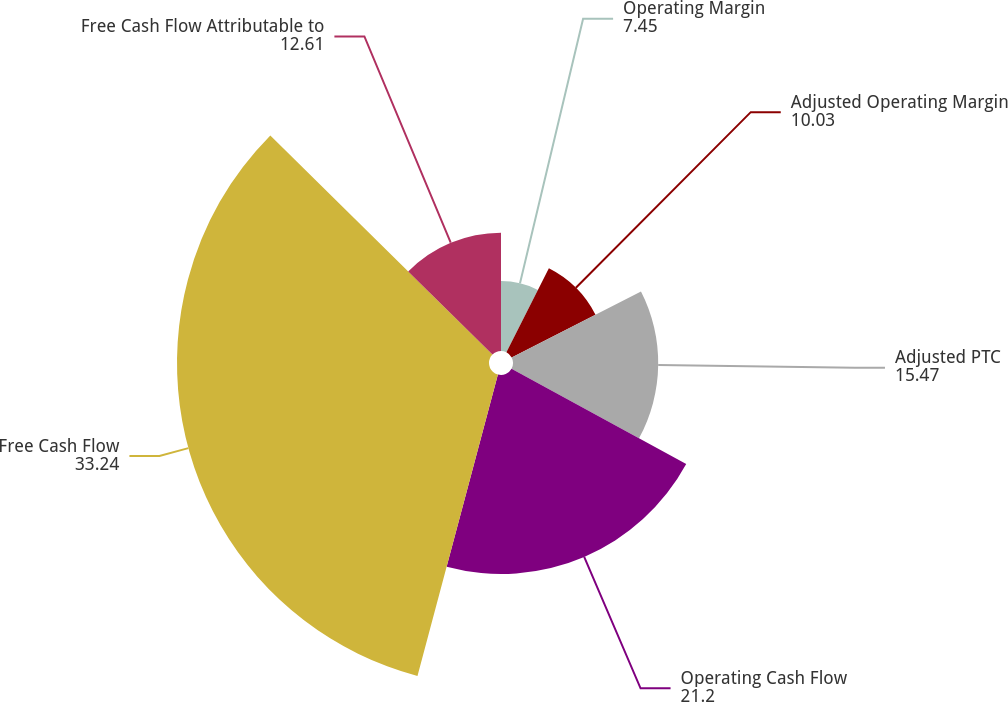Convert chart to OTSL. <chart><loc_0><loc_0><loc_500><loc_500><pie_chart><fcel>Operating Margin<fcel>Adjusted Operating Margin<fcel>Adjusted PTC<fcel>Operating Cash Flow<fcel>Free Cash Flow<fcel>Free Cash Flow Attributable to<nl><fcel>7.45%<fcel>10.03%<fcel>15.47%<fcel>21.2%<fcel>33.24%<fcel>12.61%<nl></chart> 